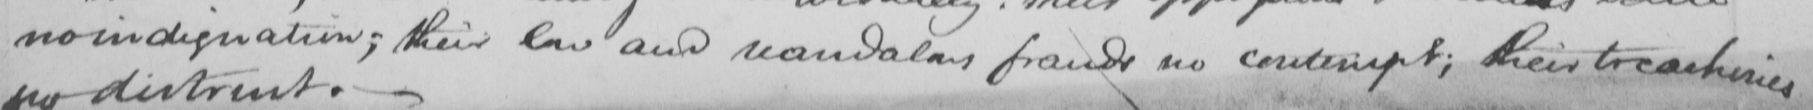What text is written in this handwritten line? no indignation ; their low and scandalous frauds no contempt ; their treacheries 